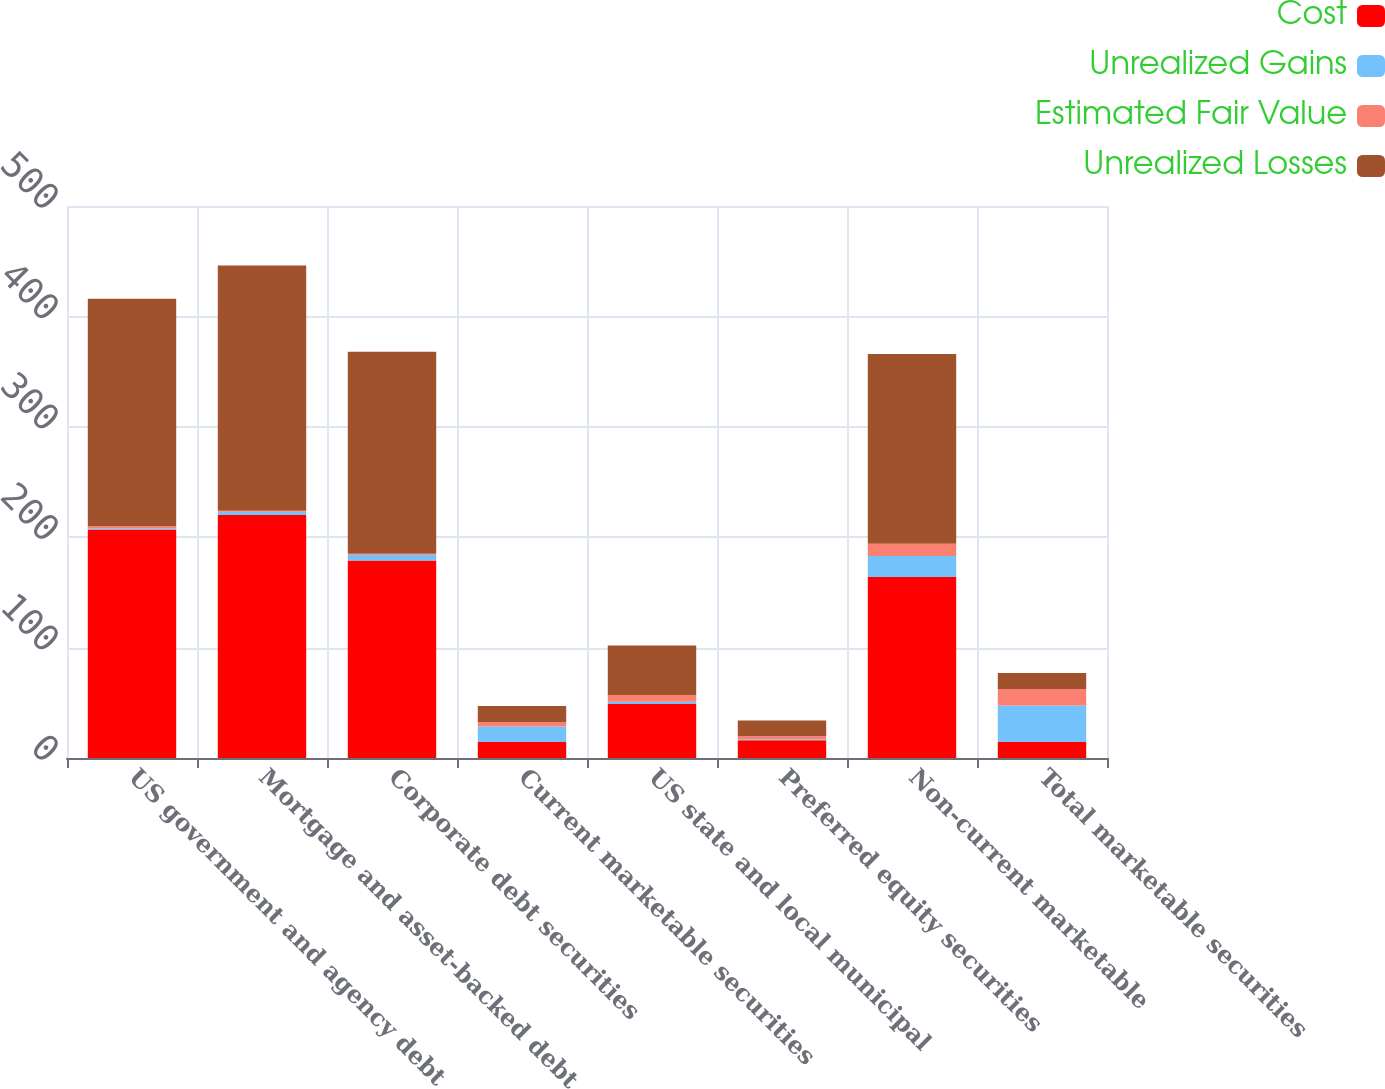<chart> <loc_0><loc_0><loc_500><loc_500><stacked_bar_chart><ecel><fcel>US government and agency debt<fcel>Mortgage and asset-backed debt<fcel>Corporate debt securities<fcel>Current marketable securities<fcel>US state and local municipal<fcel>Preferred equity securities<fcel>Non-current marketable<fcel>Total marketable securities<nl><fcel>Cost<fcel>207<fcel>220<fcel>179<fcel>14.5<fcel>49<fcel>16<fcel>164<fcel>14.5<nl><fcel>Unrealized Gains<fcel>1<fcel>3<fcel>5<fcel>14<fcel>2<fcel>1<fcel>19<fcel>33<nl><fcel>Estimated Fair Value<fcel>2<fcel>1<fcel>1<fcel>4<fcel>6<fcel>3<fcel>11<fcel>15<nl><fcel>Unrealized Losses<fcel>206<fcel>222<fcel>183<fcel>14.5<fcel>45<fcel>14<fcel>172<fcel>14.5<nl></chart> 